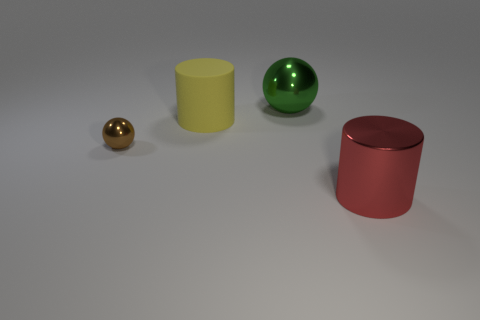Are there any other things that have the same material as the yellow object?
Ensure brevity in your answer.  No. Is there any other thing that is the same size as the brown ball?
Provide a succinct answer. No. Is there a large green sphere left of the big metallic thing that is in front of the green metallic ball?
Keep it short and to the point. Yes. There is a thing that is behind the big red object and on the right side of the matte thing; what material is it?
Make the answer very short. Metal. What is the shape of the green object that is made of the same material as the big red cylinder?
Offer a terse response. Sphere. Is the thing that is behind the large yellow cylinder made of the same material as the tiny thing?
Keep it short and to the point. Yes. What is the material of the big cylinder on the right side of the large sphere?
Give a very brief answer. Metal. There is a thing that is behind the large cylinder behind the red object; how big is it?
Your answer should be compact. Large. How many cyan cylinders have the same size as the red shiny cylinder?
Provide a short and direct response. 0. There is a red metallic object; are there any metal cylinders right of it?
Make the answer very short. No. 